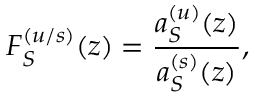Convert formula to latex. <formula><loc_0><loc_0><loc_500><loc_500>F _ { S } ^ { ( u / s ) } ( z ) = \frac { a _ { S } ^ { ( u ) } ( z ) } { a _ { S } ^ { ( s ) } ( z ) } ,</formula> 